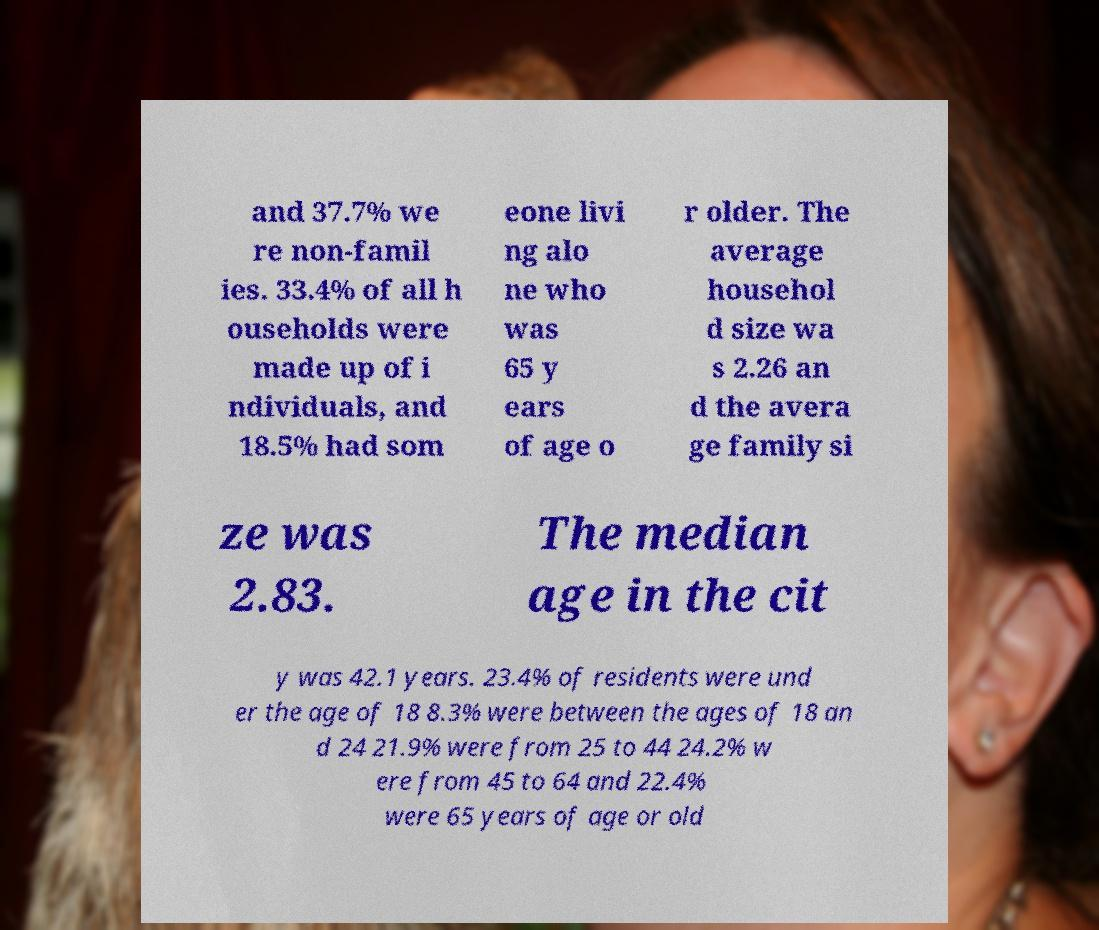Please read and relay the text visible in this image. What does it say? and 37.7% we re non-famil ies. 33.4% of all h ouseholds were made up of i ndividuals, and 18.5% had som eone livi ng alo ne who was 65 y ears of age o r older. The average househol d size wa s 2.26 an d the avera ge family si ze was 2.83. The median age in the cit y was 42.1 years. 23.4% of residents were und er the age of 18 8.3% were between the ages of 18 an d 24 21.9% were from 25 to 44 24.2% w ere from 45 to 64 and 22.4% were 65 years of age or old 